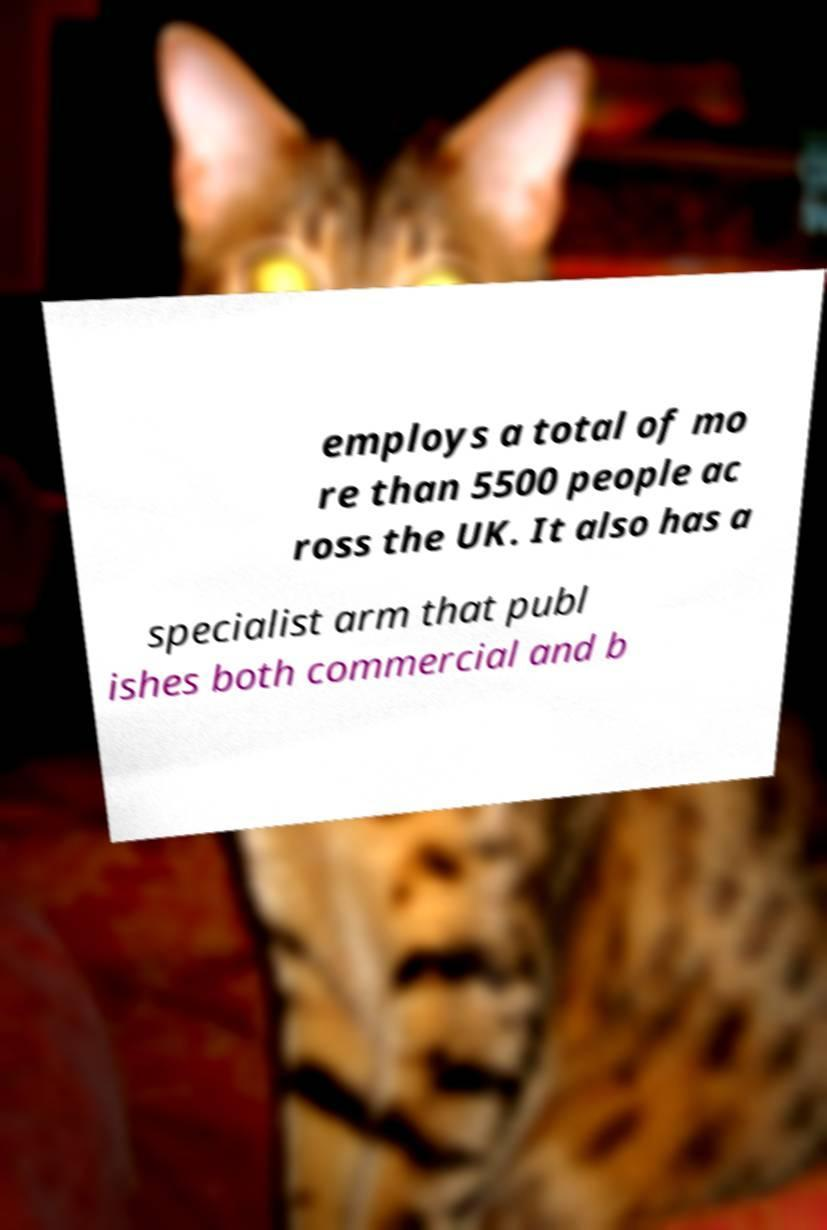Could you extract and type out the text from this image? employs a total of mo re than 5500 people ac ross the UK. It also has a specialist arm that publ ishes both commercial and b 